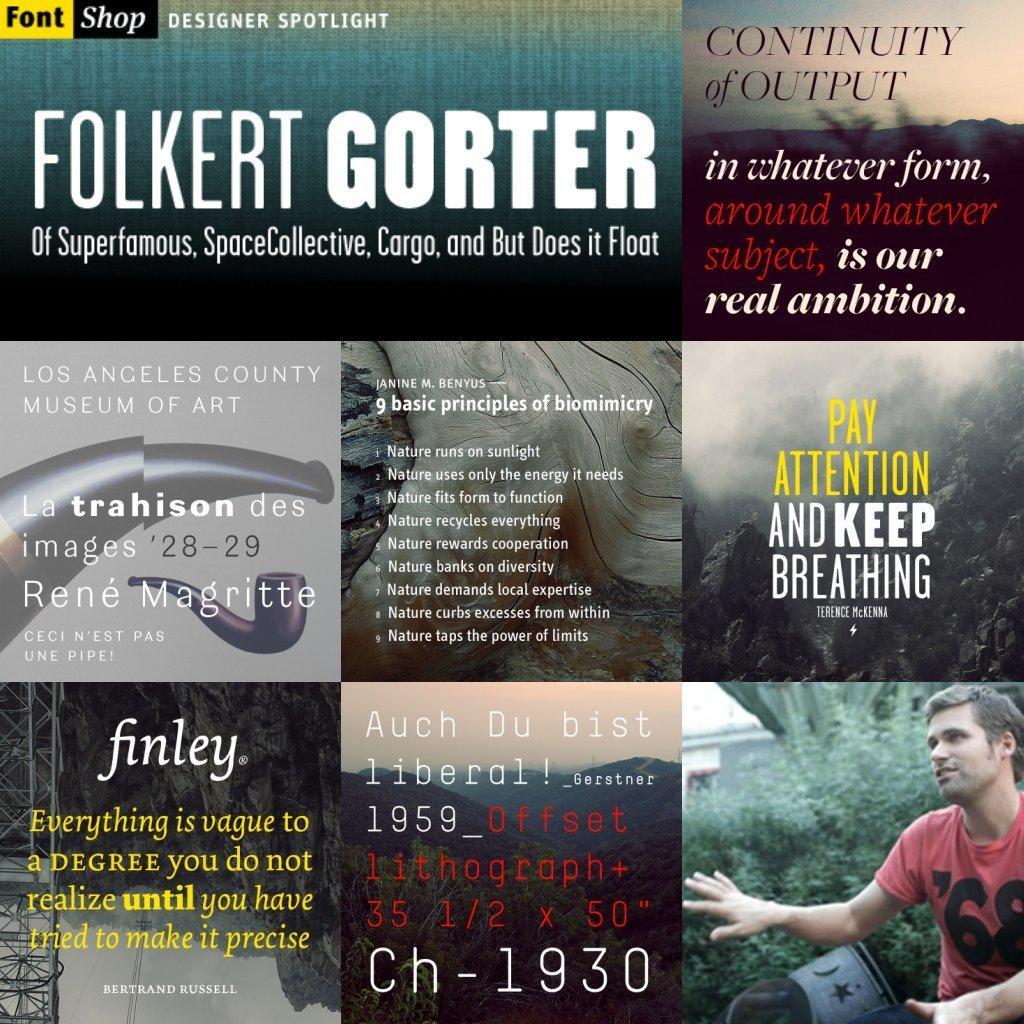Describe this image in one or two sentences. This image is a collage picture. In this image we can see pictures of persons and text. 